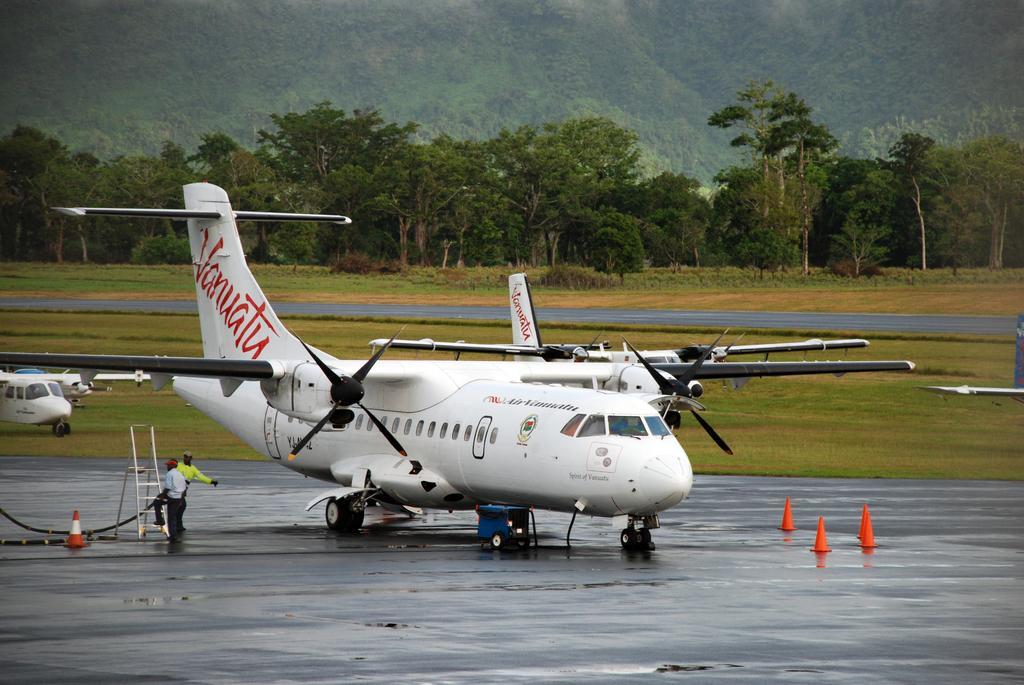Please provide a concise description of this image. As we can see in the image there are planes, two people standing on earth's surface, ladder, traffic cones, grass, trees and sky. 